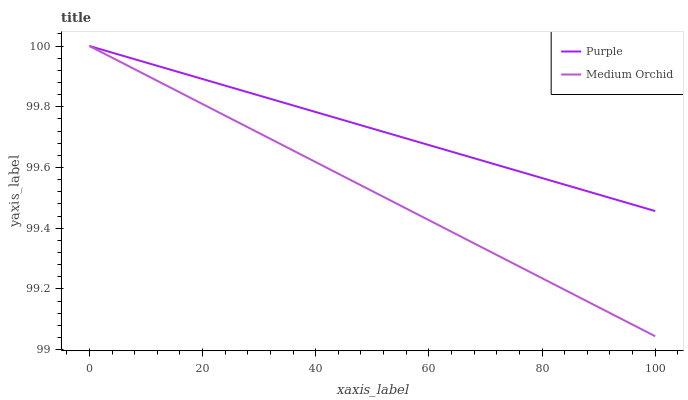Does Medium Orchid have the minimum area under the curve?
Answer yes or no. Yes. Does Purple have the maximum area under the curve?
Answer yes or no. Yes. Does Medium Orchid have the maximum area under the curve?
Answer yes or no. No. Is Medium Orchid the smoothest?
Answer yes or no. Yes. Is Purple the roughest?
Answer yes or no. Yes. Is Medium Orchid the roughest?
Answer yes or no. No. Does Medium Orchid have the lowest value?
Answer yes or no. Yes. Does Medium Orchid have the highest value?
Answer yes or no. Yes. Does Purple intersect Medium Orchid?
Answer yes or no. Yes. Is Purple less than Medium Orchid?
Answer yes or no. No. Is Purple greater than Medium Orchid?
Answer yes or no. No. 